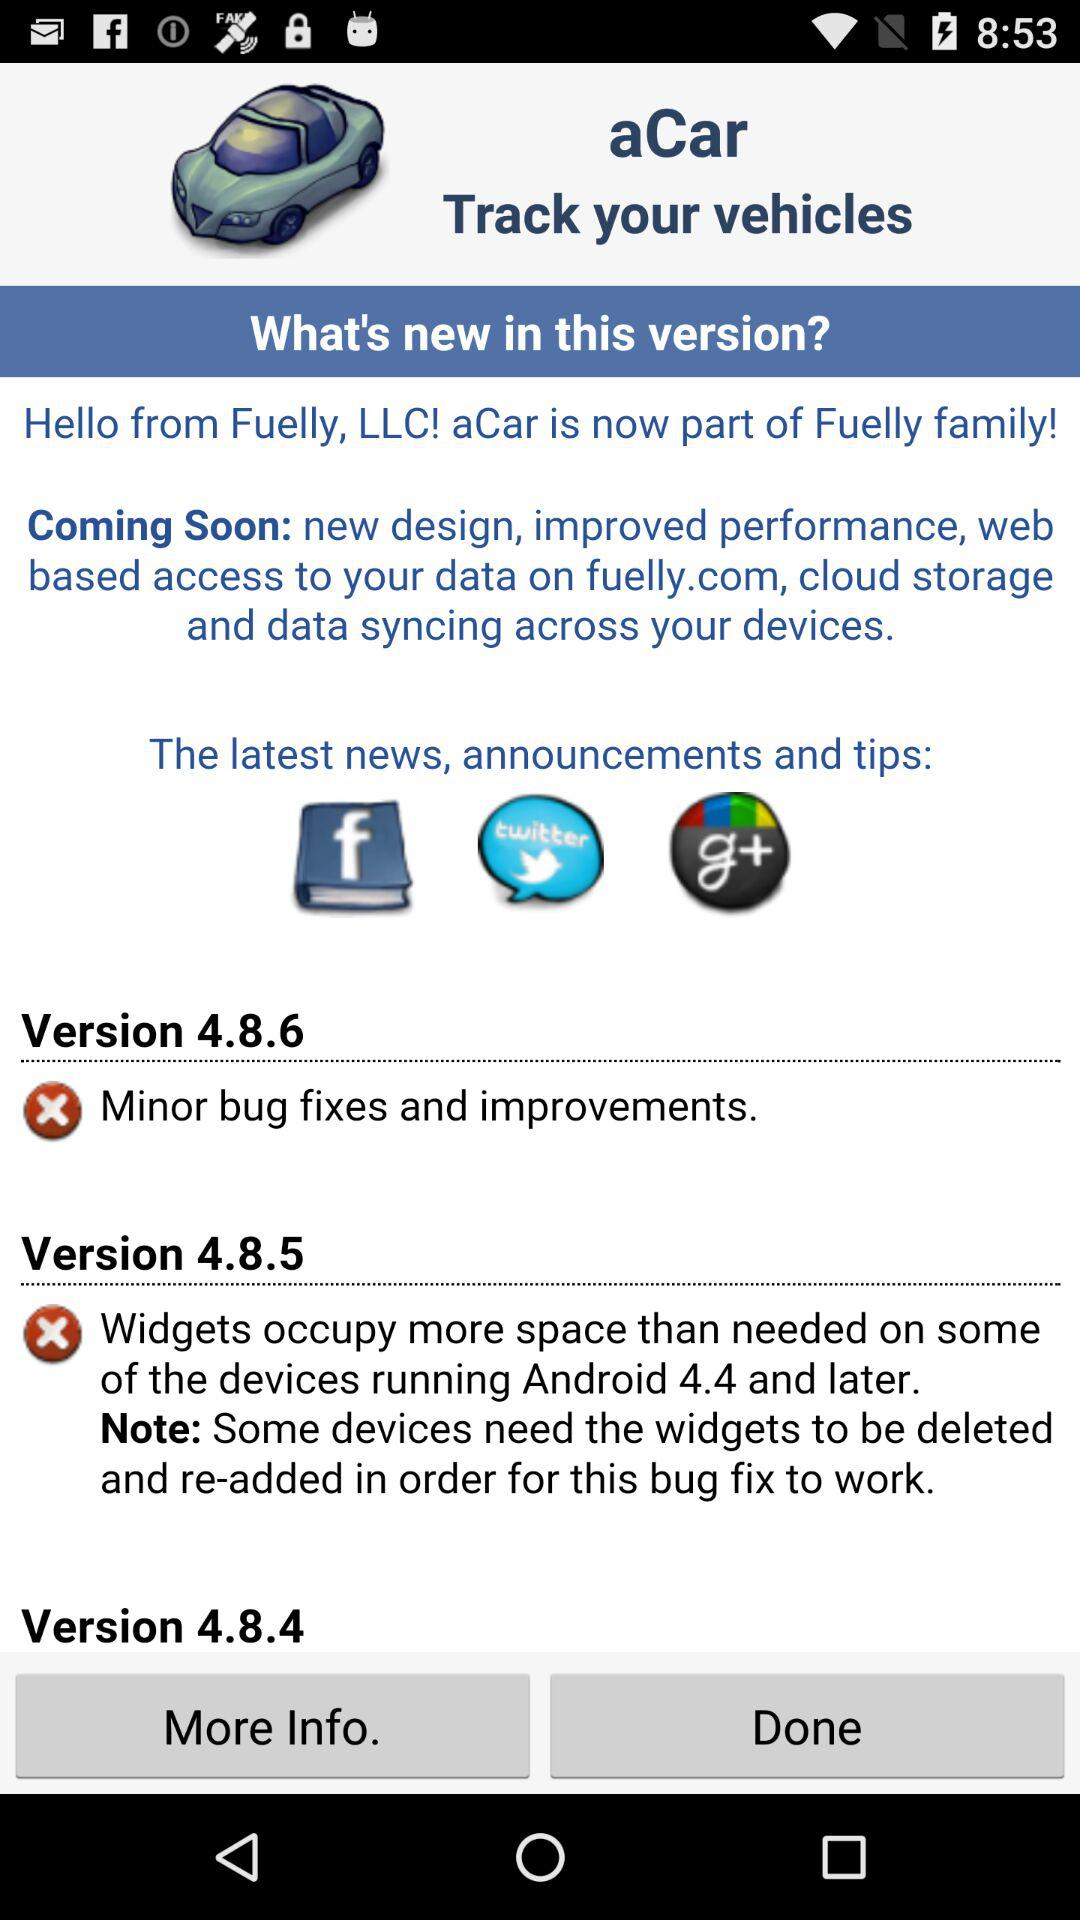What is the latest version? The latest version is 4.8.6. 